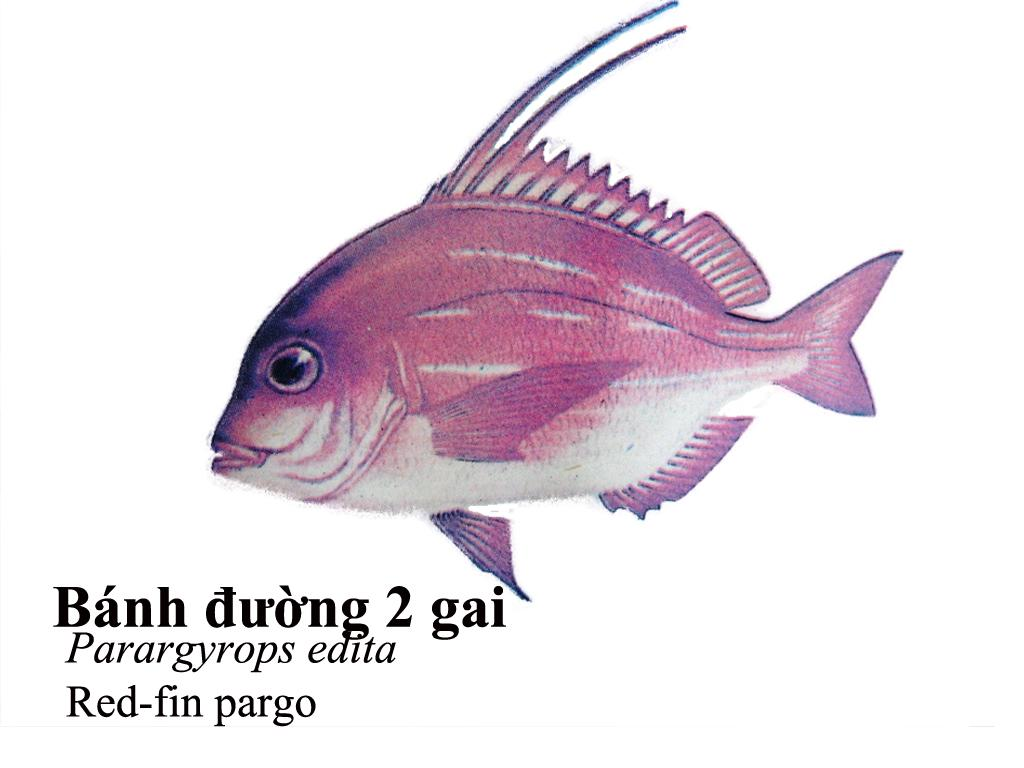What is depicted in the image? There is a diagram of a fish in the image. What else can be found on the image besides the fish diagram? There are words and a number on the image. How many snails are present in the image? There are no snails present in the image; it features a diagram of a fish, words, and a number. What is the belief system associated with the image? There is no indication of any belief system associated with the image; it is a diagram of a fish with words and a number. 